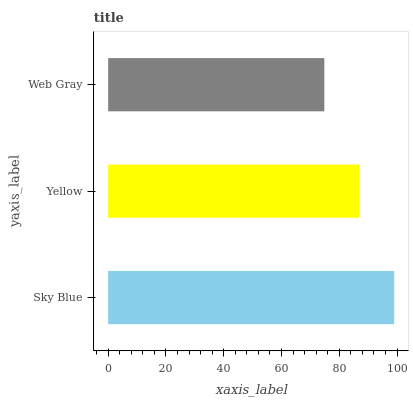Is Web Gray the minimum?
Answer yes or no. Yes. Is Sky Blue the maximum?
Answer yes or no. Yes. Is Yellow the minimum?
Answer yes or no. No. Is Yellow the maximum?
Answer yes or no. No. Is Sky Blue greater than Yellow?
Answer yes or no. Yes. Is Yellow less than Sky Blue?
Answer yes or no. Yes. Is Yellow greater than Sky Blue?
Answer yes or no. No. Is Sky Blue less than Yellow?
Answer yes or no. No. Is Yellow the high median?
Answer yes or no. Yes. Is Yellow the low median?
Answer yes or no. Yes. Is Sky Blue the high median?
Answer yes or no. No. Is Sky Blue the low median?
Answer yes or no. No. 